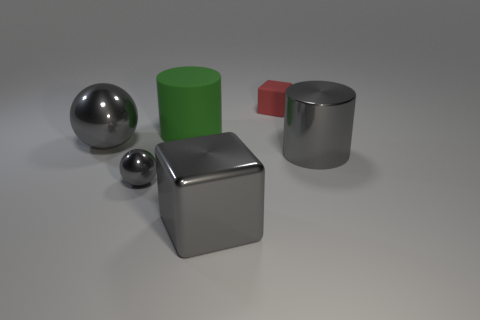Subtract all gray cubes. How many cubes are left? 1 Add 1 gray metallic cubes. How many objects exist? 7 Subtract 1 cubes. How many cubes are left? 1 Subtract all cubes. How many objects are left? 4 Subtract all blue spheres. Subtract all gray cubes. How many spheres are left? 2 Subtract all green cylinders. How many gray cubes are left? 1 Subtract all large gray metal balls. Subtract all large cyan things. How many objects are left? 5 Add 6 red rubber objects. How many red rubber objects are left? 7 Add 3 big gray spheres. How many big gray spheres exist? 4 Subtract 0 purple cylinders. How many objects are left? 6 